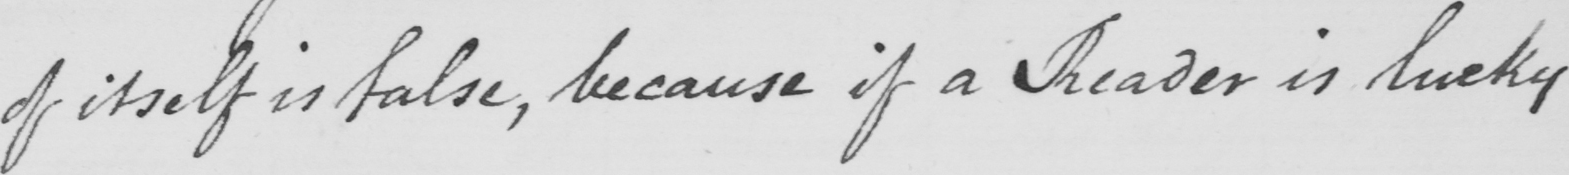Transcribe the text shown in this historical manuscript line. of itself is false , because if a Reader is lucky 